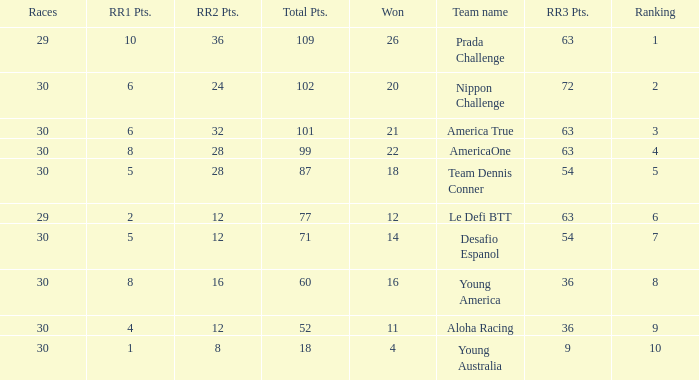How many rr2 points are awarded for a win, given that the total is 11? 1.0. 